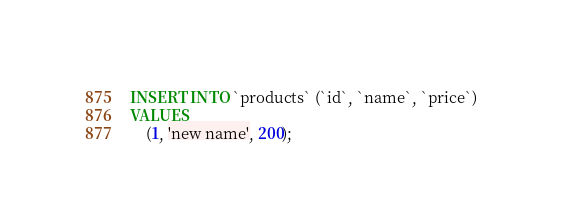<code> <loc_0><loc_0><loc_500><loc_500><_SQL_>INSERT INTO `products` (`id`, `name`, `price`)
VALUES
	(1, 'new name', 200);
</code> 